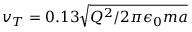<formula> <loc_0><loc_0><loc_500><loc_500>v _ { T } = 0 . 1 3 \sqrt { Q ^ { 2 } / 2 \pi \epsilon _ { 0 } m a }</formula> 